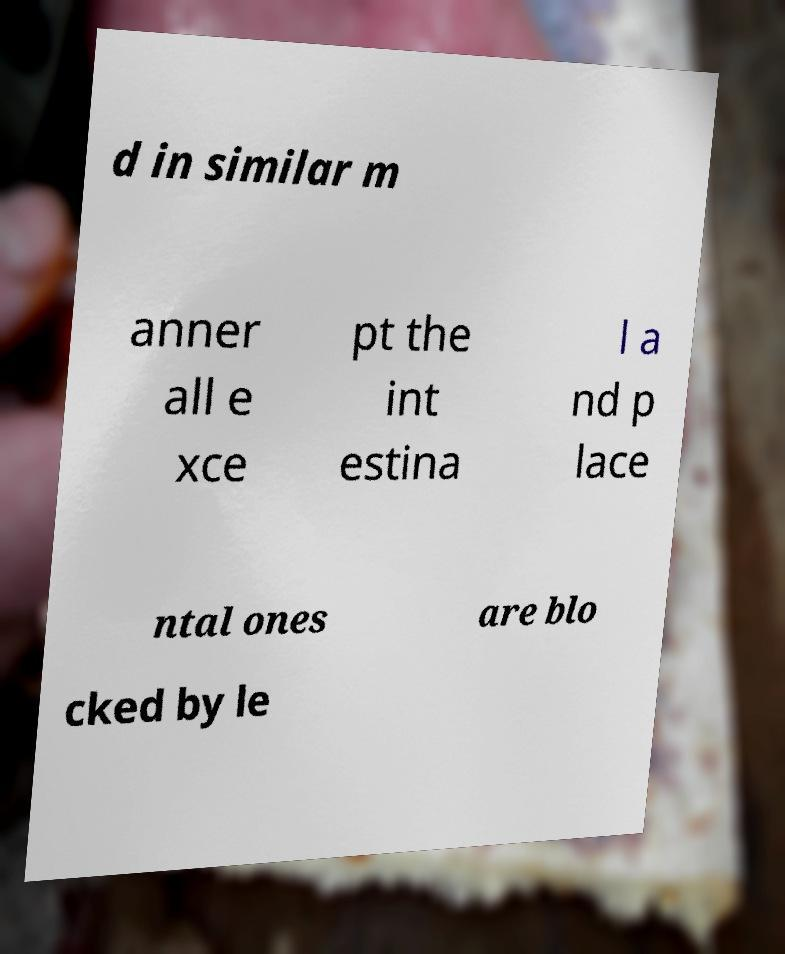Could you extract and type out the text from this image? d in similar m anner all e xce pt the int estina l a nd p lace ntal ones are blo cked by le 